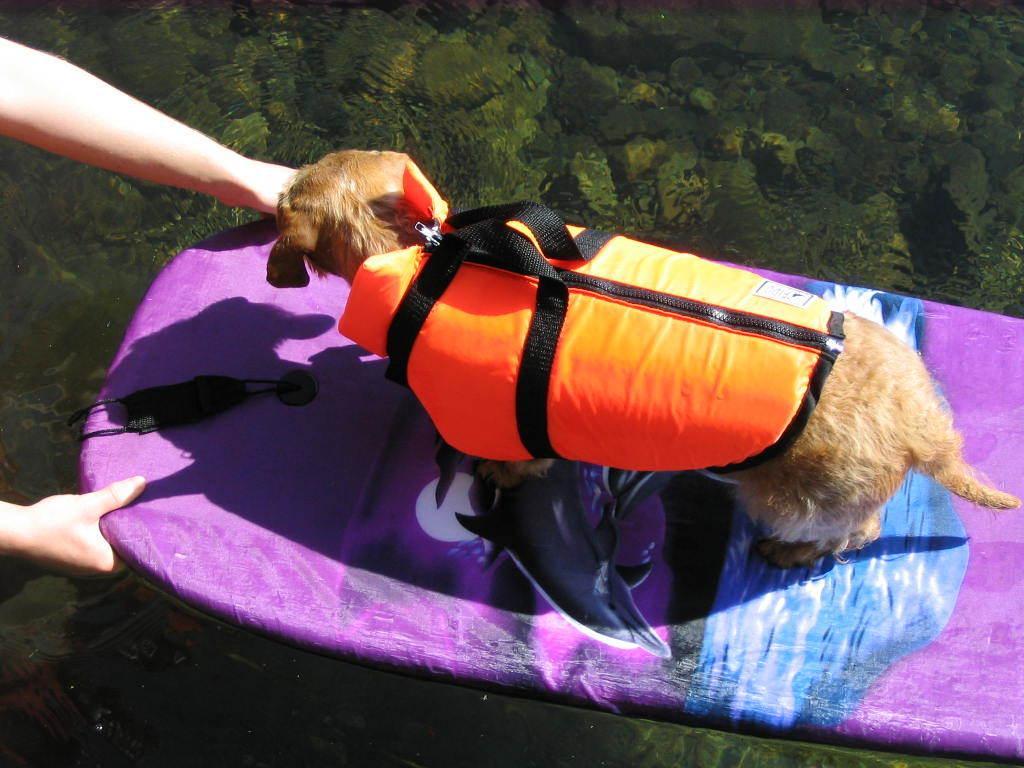Could you give a brief overview of what you see in this image? In the center of the image we can see human hands holding one flat object. On the flat object, we can see one dog. And we can see the dog is wearing a jacket. In the background, we can see water and stones in the water. 